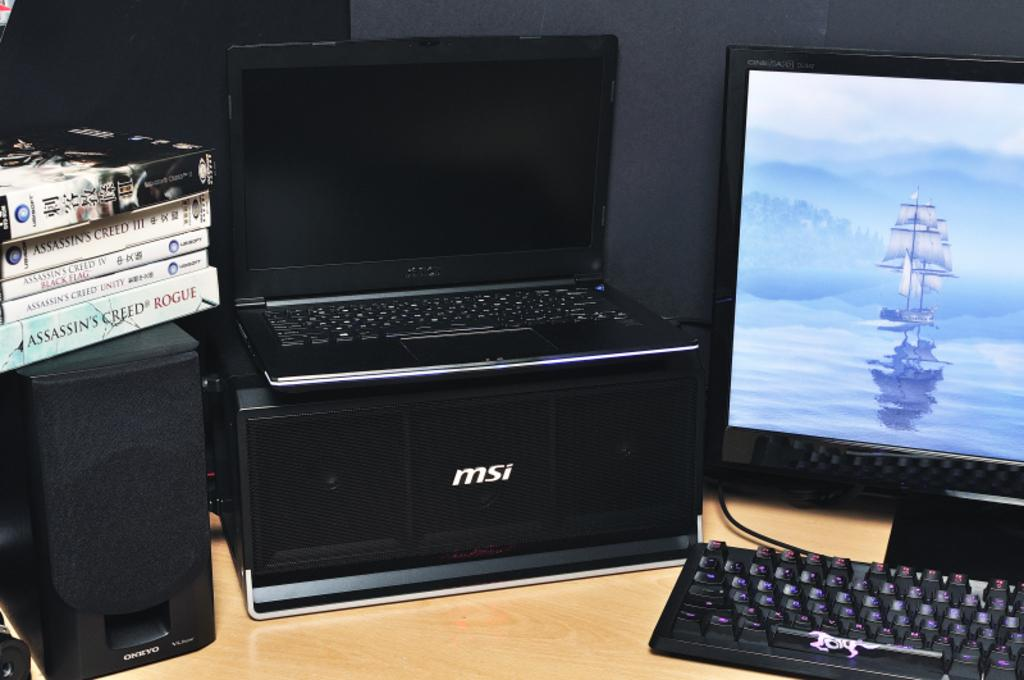<image>
Describe the image concisely. Technology set up with a laptop on a MSI box 